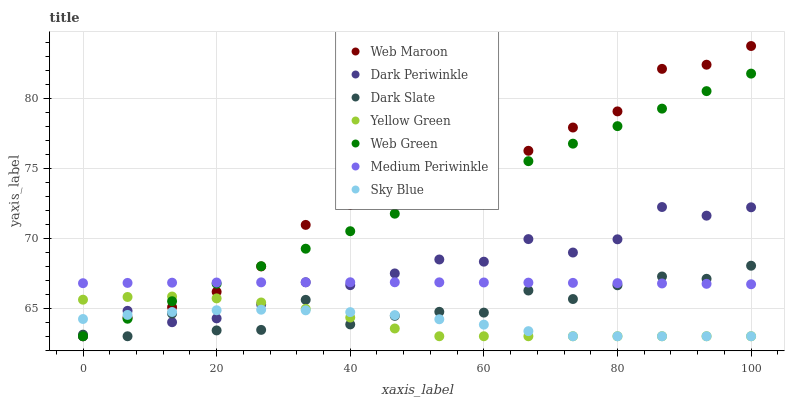Does Sky Blue have the minimum area under the curve?
Answer yes or no. Yes. Does Web Maroon have the maximum area under the curve?
Answer yes or no. Yes. Does Medium Periwinkle have the minimum area under the curve?
Answer yes or no. No. Does Medium Periwinkle have the maximum area under the curve?
Answer yes or no. No. Is Web Green the smoothest?
Answer yes or no. Yes. Is Dark Slate the roughest?
Answer yes or no. Yes. Is Web Maroon the smoothest?
Answer yes or no. No. Is Web Maroon the roughest?
Answer yes or no. No. Does Yellow Green have the lowest value?
Answer yes or no. Yes. Does Medium Periwinkle have the lowest value?
Answer yes or no. No. Does Web Maroon have the highest value?
Answer yes or no. Yes. Does Medium Periwinkle have the highest value?
Answer yes or no. No. Is Sky Blue less than Medium Periwinkle?
Answer yes or no. Yes. Is Medium Periwinkle greater than Yellow Green?
Answer yes or no. Yes. Does Web Green intersect Web Maroon?
Answer yes or no. Yes. Is Web Green less than Web Maroon?
Answer yes or no. No. Is Web Green greater than Web Maroon?
Answer yes or no. No. Does Sky Blue intersect Medium Periwinkle?
Answer yes or no. No. 